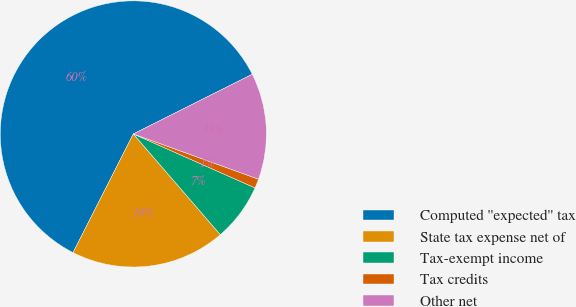Convert chart to OTSL. <chart><loc_0><loc_0><loc_500><loc_500><pie_chart><fcel>Computed ''expected'' tax<fcel>State tax expense net of<fcel>Tax-exempt income<fcel>Tax credits<fcel>Other net<nl><fcel>60.11%<fcel>18.82%<fcel>7.02%<fcel>1.12%<fcel>12.92%<nl></chart> 